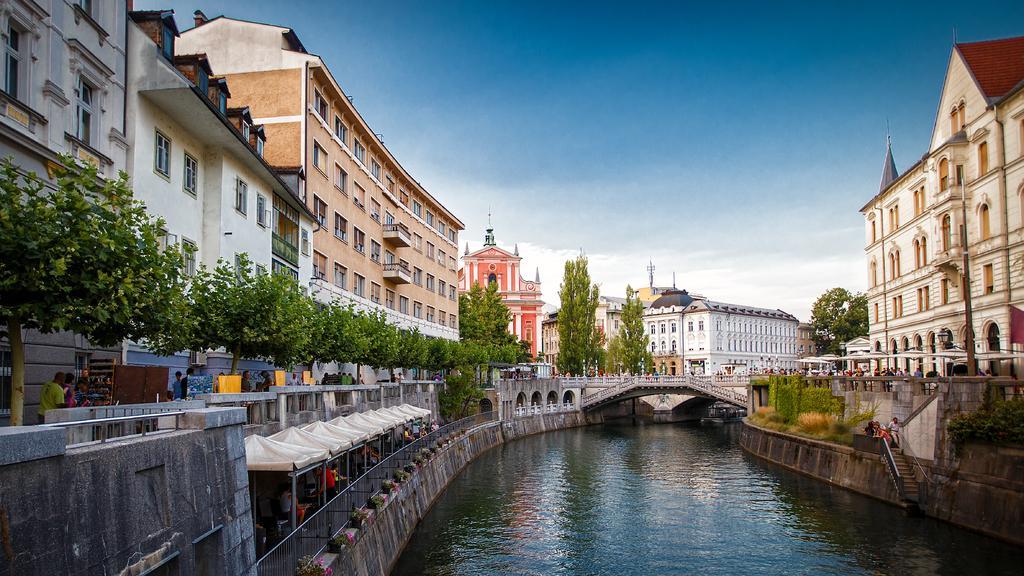How would you summarize this image in a sentence or two? In the image I can see canal in which there is a bridge and also I can see some trees, plants, buildings and some other people. 